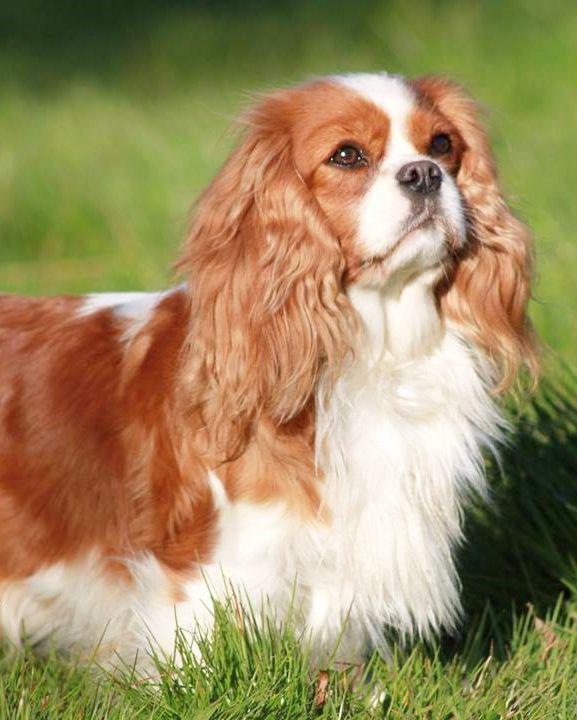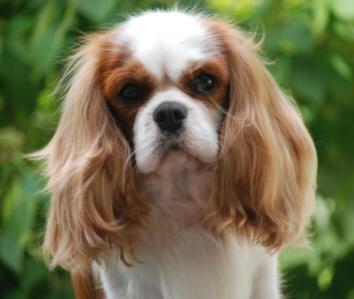The first image is the image on the left, the second image is the image on the right. For the images shown, is this caption "You can clearly see at least one dogs leg, unobstructed by hanging fur." true? Answer yes or no. No. 